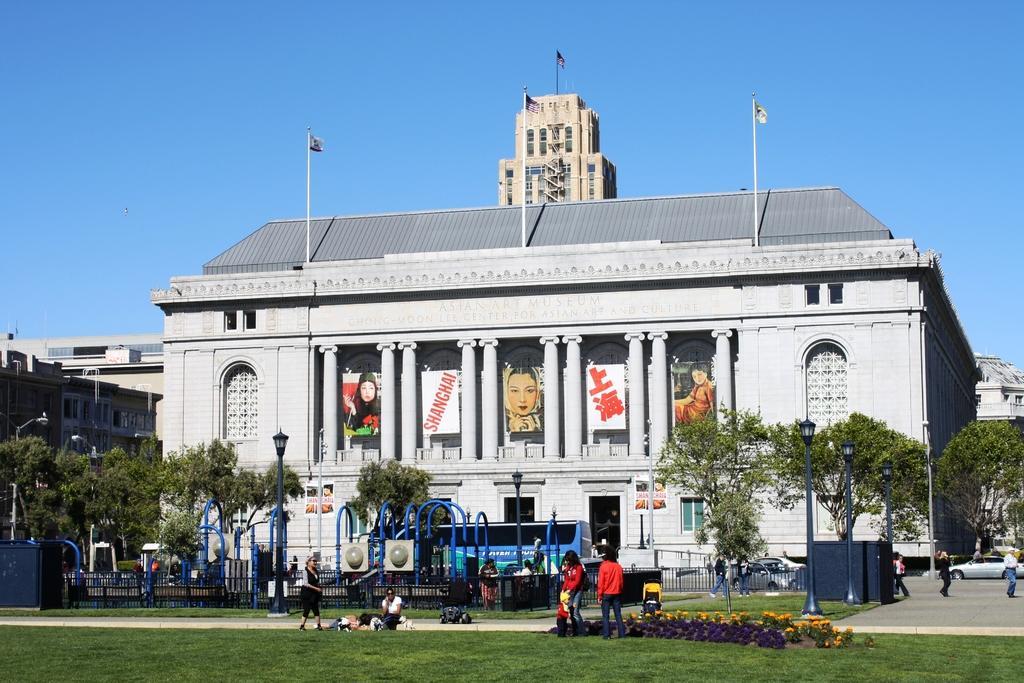Could you give a brief overview of what you see in this image? In this image I can see few people some are walking and some are sitting, the person in front is wearing red shirt, blue pant. Background I can see few vehicles , light poles, trees in green color, buildings in gray and cream color and the sky is in blue color. 